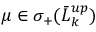<formula> <loc_0><loc_0><loc_500><loc_500>\mu \in \sigma _ { + } ( \bar { L } _ { k } ^ { u p } )</formula> 